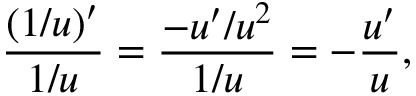Convert formula to latex. <formula><loc_0><loc_0><loc_500><loc_500>{ \frac { ( 1 / u ) ^ { \prime } } { 1 / u } } = { \frac { - u ^ { \prime } / u ^ { 2 } } { 1 / u } } = - { \frac { u ^ { \prime } } { u } } ,</formula> 